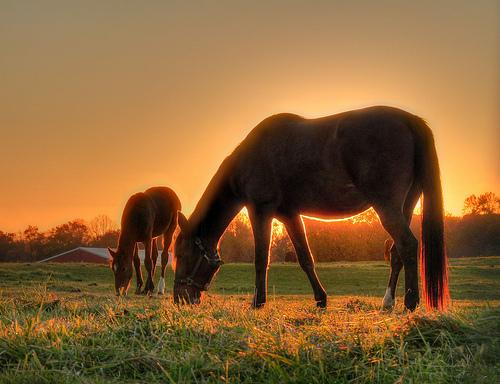Explain the position and details of a relatively smaller object in the image related to the main subject. The long tail of the horse is found towards its rear in the image, with a visible length and thickness, highlighting the horse's strong and healthy appearance. Describe the sky's color and status, and the relation with the main subject. The sky is a beautiful blend of orange and yellow hues with a bright yellow sunset, and seemingly cloudless. It magnificently backlights the main subject: a brown horse eating grass in the field. Discuss any relevant details of the second horse's appearance and position in the image. The second horse, smaller than the main subject, has its head down and appears to be eating grass as well. Its head and front legs can be seen closer to the bottom right area of the image. In your own words, describe what you believe is the primary focus of the image and the action they are participating in. The main subject is a large brown horse eating green grass in a field with another horse nearby, during a beautiful sunset. If you were to advertise a product in this image, what would you emphasize and how would you describe it for potential customers? Introducing our line of organic horse feed that keeps your horses healthy, active, and satisfied! Witness the beauty of your horses grazing happily in the pristine fields, as seen with the majestic horses in this image. For the visual entailment task, identify the relationship between the main subject and the surrounding elements in the image. The large brown horse with a white spot on its leg is eating grass in a field while a smaller horse grazes nearby. Their surroundings include a visually-striking sunset, vibrant green grass, a red building with a white roof, and distant trees. Mention the significant colors you can observe in the environment and any notable features of the primary subject. The dominant colors in the image include green grass, a bright yellow sunset, and a brown horse with a white spot on its leg. Select one detailed feature of the horse and provide a brief description of it. A unique feature of the large brown horse is its pointy ear, signifying it is attentive and aware of its surroundings while grazing in the field. Please describe the scene and surroundings of the image containing the horse. The image depicts a beautiful scene of two horses grazing in a lush green field with a mesmerizing orange and yellow sunset, distant trees, and a red building with a white roof in the background. For the referential expression grounding task, find the hidden building in the background and describe its attributes. The building is a distant red barn with a white roof, partially obscured by the hill and background elements, blending seamlessly into the picturesque scene. I saw a large white horse in the field. All the horses described in the image are brown, not white. The sunset in the background is blue. The sunset is described as "bright yellow," not blue. Is the sky filled with clouds? The instructions given describe the sky as both "clear" and "orange," but not filled with clouds. The horse is wearing a hat. No, it's not mentioned in the image. The trees in the background are very close to the horses. The trees are described as being "far" and "distant," not close to the horses. Is the grass at the prairie short and yellow? The grass is described as long and green, not short and yellow. There is a green roof on the red building. The roof of the red building is described as "white," not green. Are there three horses in the field? The instructions mention two horses in the field, not three. Do you see the short tail of the horse? The tail of the horse is consistently described as "long," not short. The small horse has no white spots on its leg. One of the larger horses is described as having a "white spot on its leg," while there is no mention of the smaller horse not having any white spots. 